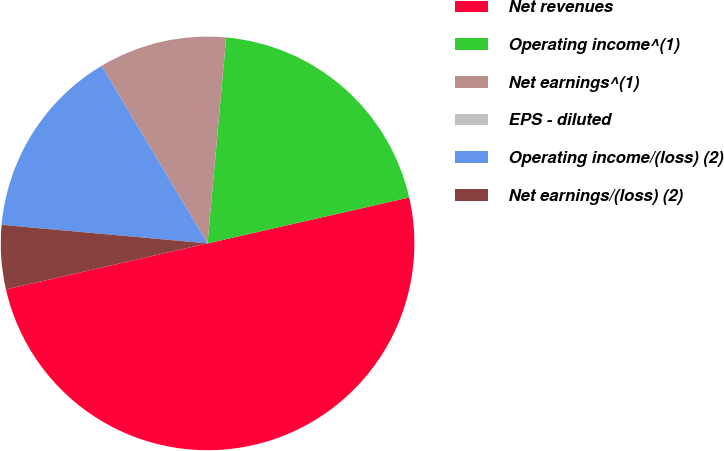Convert chart to OTSL. <chart><loc_0><loc_0><loc_500><loc_500><pie_chart><fcel>Net revenues<fcel>Operating income^(1)<fcel>Net earnings^(1)<fcel>EPS - diluted<fcel>Operating income/(loss) (2)<fcel>Net earnings/(loss) (2)<nl><fcel>49.99%<fcel>20.0%<fcel>10.0%<fcel>0.0%<fcel>15.0%<fcel>5.0%<nl></chart> 